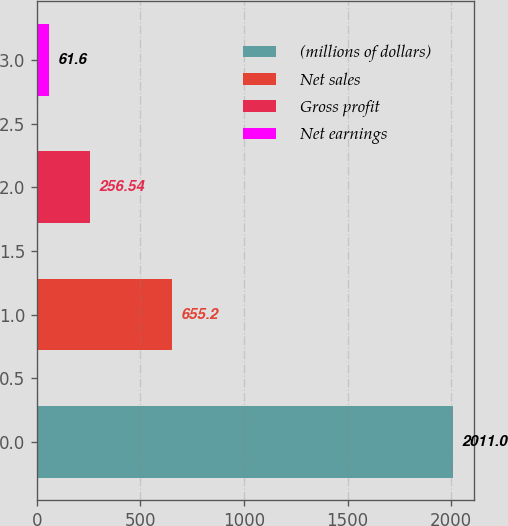<chart> <loc_0><loc_0><loc_500><loc_500><bar_chart><fcel>(millions of dollars)<fcel>Net sales<fcel>Gross profit<fcel>Net earnings<nl><fcel>2011<fcel>655.2<fcel>256.54<fcel>61.6<nl></chart> 